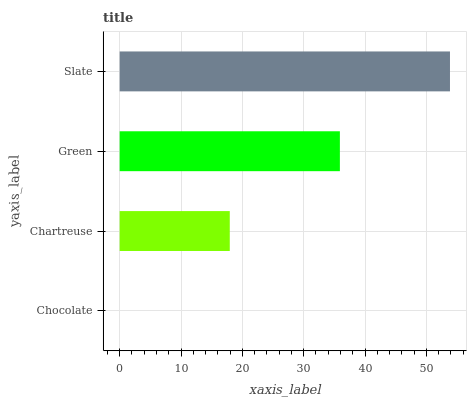Is Chocolate the minimum?
Answer yes or no. Yes. Is Slate the maximum?
Answer yes or no. Yes. Is Chartreuse the minimum?
Answer yes or no. No. Is Chartreuse the maximum?
Answer yes or no. No. Is Chartreuse greater than Chocolate?
Answer yes or no. Yes. Is Chocolate less than Chartreuse?
Answer yes or no. Yes. Is Chocolate greater than Chartreuse?
Answer yes or no. No. Is Chartreuse less than Chocolate?
Answer yes or no. No. Is Green the high median?
Answer yes or no. Yes. Is Chartreuse the low median?
Answer yes or no. Yes. Is Chartreuse the high median?
Answer yes or no. No. Is Green the low median?
Answer yes or no. No. 